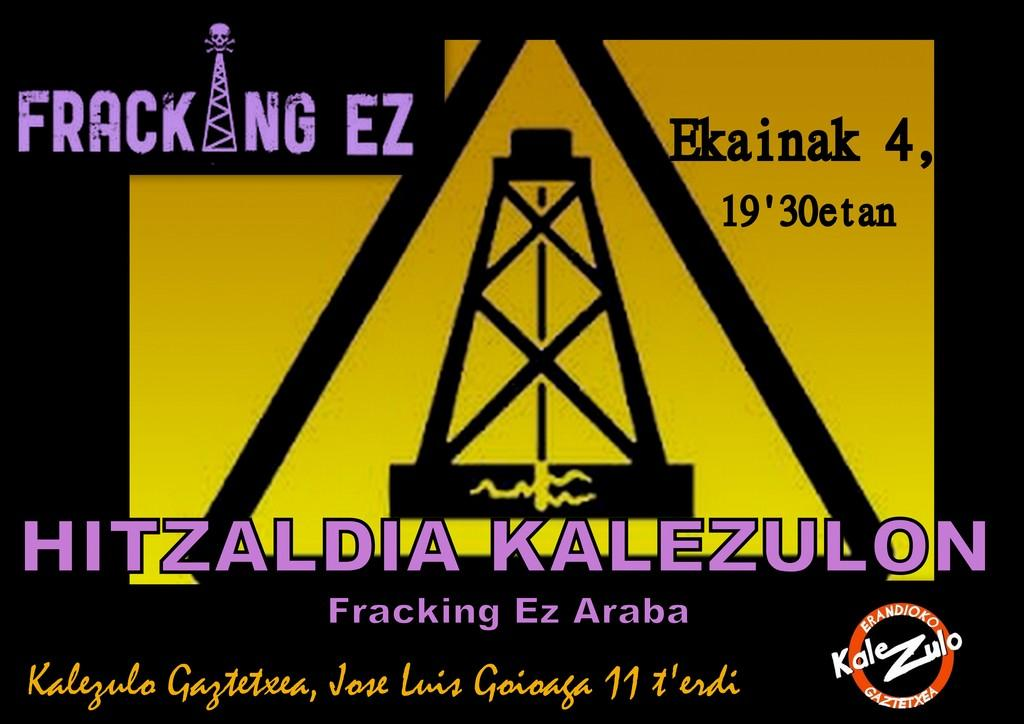What is the main object in the image? There is a poster in the image. What can be found on the poster? There is text and a picture of a skull on the poster. How does the line connect to the kick in the image? There is no line or kick present in the image; it only features a poster with text and a picture of a skull. 